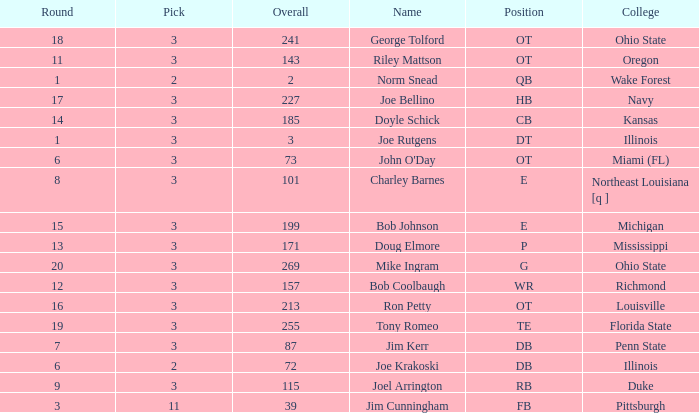How many rounds have john o'day as the name, and a pick less than 3? None. 